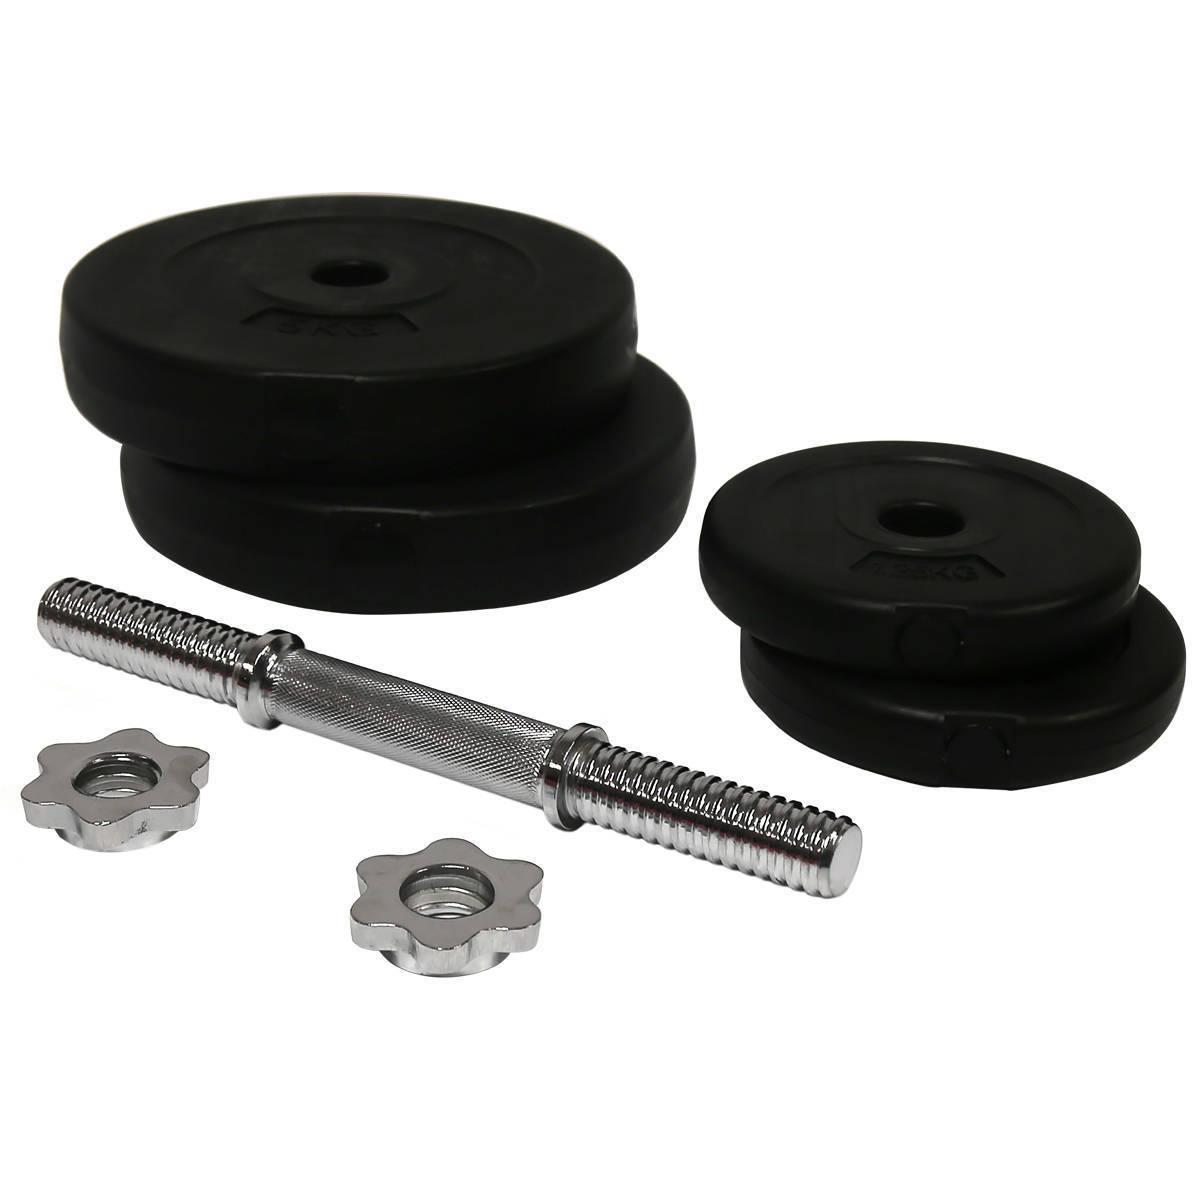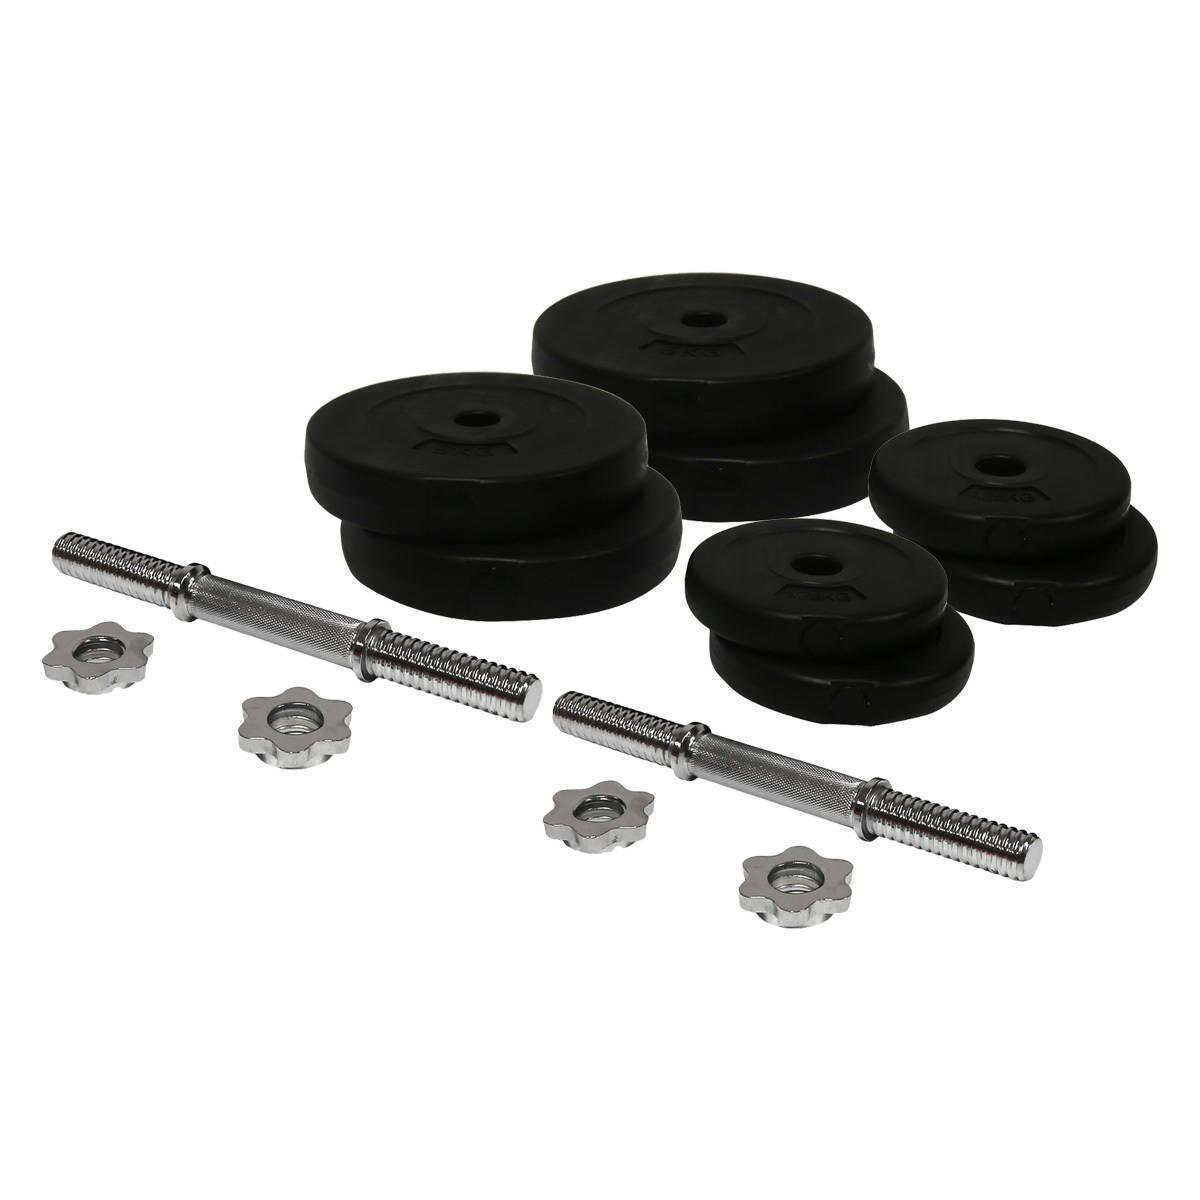The first image is the image on the left, the second image is the image on the right. Evaluate the accuracy of this statement regarding the images: "Both images include separate dumbbell parts that require assembly.". Is it true? Answer yes or no. Yes. The first image is the image on the left, the second image is the image on the right. Considering the images on both sides, is "The right image contains the disassembled parts for two barbells." valid? Answer yes or no. Yes. 